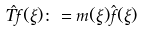<formula> <loc_0><loc_0><loc_500><loc_500>\hat { T f } ( \xi ) \colon = m ( \xi ) \hat { f } ( \xi )</formula> 